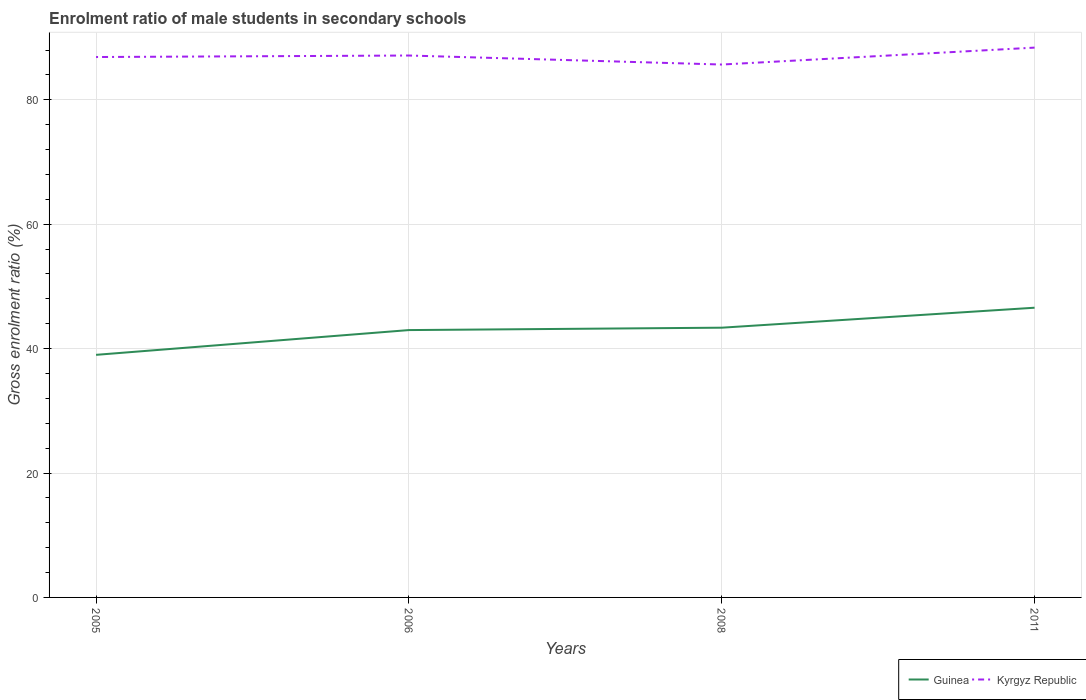How many different coloured lines are there?
Offer a terse response. 2. Does the line corresponding to Kyrgyz Republic intersect with the line corresponding to Guinea?
Provide a succinct answer. No. Across all years, what is the maximum enrolment ratio of male students in secondary schools in Kyrgyz Republic?
Your answer should be very brief. 85.67. In which year was the enrolment ratio of male students in secondary schools in Kyrgyz Republic maximum?
Your answer should be compact. 2008. What is the total enrolment ratio of male students in secondary schools in Kyrgyz Republic in the graph?
Provide a succinct answer. 1.21. What is the difference between the highest and the second highest enrolment ratio of male students in secondary schools in Kyrgyz Republic?
Make the answer very short. 2.72. What is the difference between the highest and the lowest enrolment ratio of male students in secondary schools in Kyrgyz Republic?
Give a very brief answer. 2. How many years are there in the graph?
Provide a succinct answer. 4. What is the difference between two consecutive major ticks on the Y-axis?
Make the answer very short. 20. Are the values on the major ticks of Y-axis written in scientific E-notation?
Give a very brief answer. No. Does the graph contain grids?
Give a very brief answer. Yes. What is the title of the graph?
Offer a very short reply. Enrolment ratio of male students in secondary schools. What is the label or title of the Y-axis?
Ensure brevity in your answer.  Gross enrolment ratio (%). What is the Gross enrolment ratio (%) of Guinea in 2005?
Your answer should be very brief. 39. What is the Gross enrolment ratio (%) of Kyrgyz Republic in 2005?
Make the answer very short. 86.87. What is the Gross enrolment ratio (%) in Guinea in 2006?
Provide a succinct answer. 42.98. What is the Gross enrolment ratio (%) of Kyrgyz Republic in 2006?
Offer a very short reply. 87.12. What is the Gross enrolment ratio (%) of Guinea in 2008?
Your answer should be very brief. 43.36. What is the Gross enrolment ratio (%) in Kyrgyz Republic in 2008?
Give a very brief answer. 85.67. What is the Gross enrolment ratio (%) of Guinea in 2011?
Your answer should be very brief. 46.57. What is the Gross enrolment ratio (%) of Kyrgyz Republic in 2011?
Offer a very short reply. 88.39. Across all years, what is the maximum Gross enrolment ratio (%) of Guinea?
Your answer should be very brief. 46.57. Across all years, what is the maximum Gross enrolment ratio (%) of Kyrgyz Republic?
Your answer should be very brief. 88.39. Across all years, what is the minimum Gross enrolment ratio (%) of Guinea?
Ensure brevity in your answer.  39. Across all years, what is the minimum Gross enrolment ratio (%) of Kyrgyz Republic?
Your response must be concise. 85.67. What is the total Gross enrolment ratio (%) of Guinea in the graph?
Give a very brief answer. 171.91. What is the total Gross enrolment ratio (%) in Kyrgyz Republic in the graph?
Make the answer very short. 348.04. What is the difference between the Gross enrolment ratio (%) of Guinea in 2005 and that in 2006?
Keep it short and to the point. -3.98. What is the difference between the Gross enrolment ratio (%) in Kyrgyz Republic in 2005 and that in 2006?
Ensure brevity in your answer.  -0.24. What is the difference between the Gross enrolment ratio (%) in Guinea in 2005 and that in 2008?
Give a very brief answer. -4.37. What is the difference between the Gross enrolment ratio (%) in Kyrgyz Republic in 2005 and that in 2008?
Offer a terse response. 1.21. What is the difference between the Gross enrolment ratio (%) in Guinea in 2005 and that in 2011?
Provide a succinct answer. -7.58. What is the difference between the Gross enrolment ratio (%) in Kyrgyz Republic in 2005 and that in 2011?
Ensure brevity in your answer.  -1.51. What is the difference between the Gross enrolment ratio (%) in Guinea in 2006 and that in 2008?
Offer a terse response. -0.38. What is the difference between the Gross enrolment ratio (%) of Kyrgyz Republic in 2006 and that in 2008?
Keep it short and to the point. 1.45. What is the difference between the Gross enrolment ratio (%) of Guinea in 2006 and that in 2011?
Give a very brief answer. -3.6. What is the difference between the Gross enrolment ratio (%) in Kyrgyz Republic in 2006 and that in 2011?
Your answer should be very brief. -1.27. What is the difference between the Gross enrolment ratio (%) of Guinea in 2008 and that in 2011?
Offer a terse response. -3.21. What is the difference between the Gross enrolment ratio (%) of Kyrgyz Republic in 2008 and that in 2011?
Offer a very short reply. -2.72. What is the difference between the Gross enrolment ratio (%) in Guinea in 2005 and the Gross enrolment ratio (%) in Kyrgyz Republic in 2006?
Offer a terse response. -48.12. What is the difference between the Gross enrolment ratio (%) of Guinea in 2005 and the Gross enrolment ratio (%) of Kyrgyz Republic in 2008?
Give a very brief answer. -46.67. What is the difference between the Gross enrolment ratio (%) of Guinea in 2005 and the Gross enrolment ratio (%) of Kyrgyz Republic in 2011?
Your response must be concise. -49.39. What is the difference between the Gross enrolment ratio (%) in Guinea in 2006 and the Gross enrolment ratio (%) in Kyrgyz Republic in 2008?
Your answer should be very brief. -42.69. What is the difference between the Gross enrolment ratio (%) of Guinea in 2006 and the Gross enrolment ratio (%) of Kyrgyz Republic in 2011?
Provide a short and direct response. -45.41. What is the difference between the Gross enrolment ratio (%) in Guinea in 2008 and the Gross enrolment ratio (%) in Kyrgyz Republic in 2011?
Keep it short and to the point. -45.02. What is the average Gross enrolment ratio (%) of Guinea per year?
Provide a short and direct response. 42.98. What is the average Gross enrolment ratio (%) in Kyrgyz Republic per year?
Give a very brief answer. 87.01. In the year 2005, what is the difference between the Gross enrolment ratio (%) of Guinea and Gross enrolment ratio (%) of Kyrgyz Republic?
Provide a succinct answer. -47.88. In the year 2006, what is the difference between the Gross enrolment ratio (%) of Guinea and Gross enrolment ratio (%) of Kyrgyz Republic?
Offer a very short reply. -44.14. In the year 2008, what is the difference between the Gross enrolment ratio (%) of Guinea and Gross enrolment ratio (%) of Kyrgyz Republic?
Make the answer very short. -42.3. In the year 2011, what is the difference between the Gross enrolment ratio (%) in Guinea and Gross enrolment ratio (%) in Kyrgyz Republic?
Your answer should be compact. -41.81. What is the ratio of the Gross enrolment ratio (%) of Guinea in 2005 to that in 2006?
Give a very brief answer. 0.91. What is the ratio of the Gross enrolment ratio (%) of Guinea in 2005 to that in 2008?
Offer a very short reply. 0.9. What is the ratio of the Gross enrolment ratio (%) of Kyrgyz Republic in 2005 to that in 2008?
Offer a very short reply. 1.01. What is the ratio of the Gross enrolment ratio (%) in Guinea in 2005 to that in 2011?
Offer a terse response. 0.84. What is the ratio of the Gross enrolment ratio (%) of Kyrgyz Republic in 2005 to that in 2011?
Make the answer very short. 0.98. What is the ratio of the Gross enrolment ratio (%) of Kyrgyz Republic in 2006 to that in 2008?
Your answer should be compact. 1.02. What is the ratio of the Gross enrolment ratio (%) of Guinea in 2006 to that in 2011?
Your response must be concise. 0.92. What is the ratio of the Gross enrolment ratio (%) of Kyrgyz Republic in 2006 to that in 2011?
Your answer should be very brief. 0.99. What is the ratio of the Gross enrolment ratio (%) in Guinea in 2008 to that in 2011?
Your response must be concise. 0.93. What is the ratio of the Gross enrolment ratio (%) in Kyrgyz Republic in 2008 to that in 2011?
Your answer should be compact. 0.97. What is the difference between the highest and the second highest Gross enrolment ratio (%) of Guinea?
Keep it short and to the point. 3.21. What is the difference between the highest and the second highest Gross enrolment ratio (%) of Kyrgyz Republic?
Make the answer very short. 1.27. What is the difference between the highest and the lowest Gross enrolment ratio (%) in Guinea?
Provide a succinct answer. 7.58. What is the difference between the highest and the lowest Gross enrolment ratio (%) of Kyrgyz Republic?
Keep it short and to the point. 2.72. 